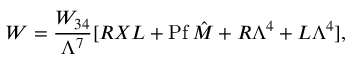<formula> <loc_0><loc_0><loc_500><loc_500>W = { \frac { W _ { 3 4 } } { \Lambda ^ { 7 } } } [ R X L + P f \, \hat { M } + R \Lambda ^ { 4 } + L \Lambda ^ { 4 } ] ,</formula> 